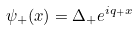Convert formula to latex. <formula><loc_0><loc_0><loc_500><loc_500>\psi _ { + } ( x ) = \Delta _ { + } e ^ { i q _ { + } x }</formula> 